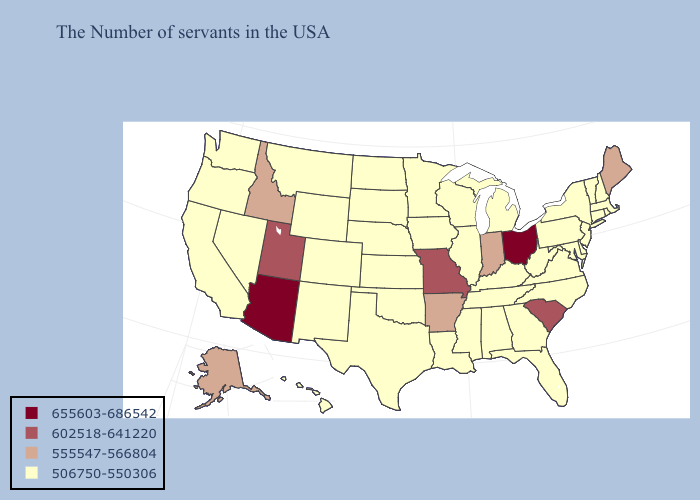Among the states that border Nebraska , does Missouri have the highest value?
Write a very short answer. Yes. What is the lowest value in states that border Kentucky?
Be succinct. 506750-550306. Does the map have missing data?
Answer briefly. No. Does Kentucky have a lower value than Ohio?
Short answer required. Yes. Name the states that have a value in the range 655603-686542?
Be succinct. Ohio, Arizona. Does Michigan have the highest value in the USA?
Answer briefly. No. Does Arizona have a lower value than Alabama?
Answer briefly. No. What is the value of Florida?
Answer briefly. 506750-550306. Name the states that have a value in the range 555547-566804?
Answer briefly. Maine, Indiana, Arkansas, Idaho, Alaska. Name the states that have a value in the range 655603-686542?
Short answer required. Ohio, Arizona. Does Maine have the highest value in the Northeast?
Be succinct. Yes. Name the states that have a value in the range 655603-686542?
Give a very brief answer. Ohio, Arizona. How many symbols are there in the legend?
Give a very brief answer. 4. Among the states that border Arkansas , does Mississippi have the lowest value?
Concise answer only. Yes. 